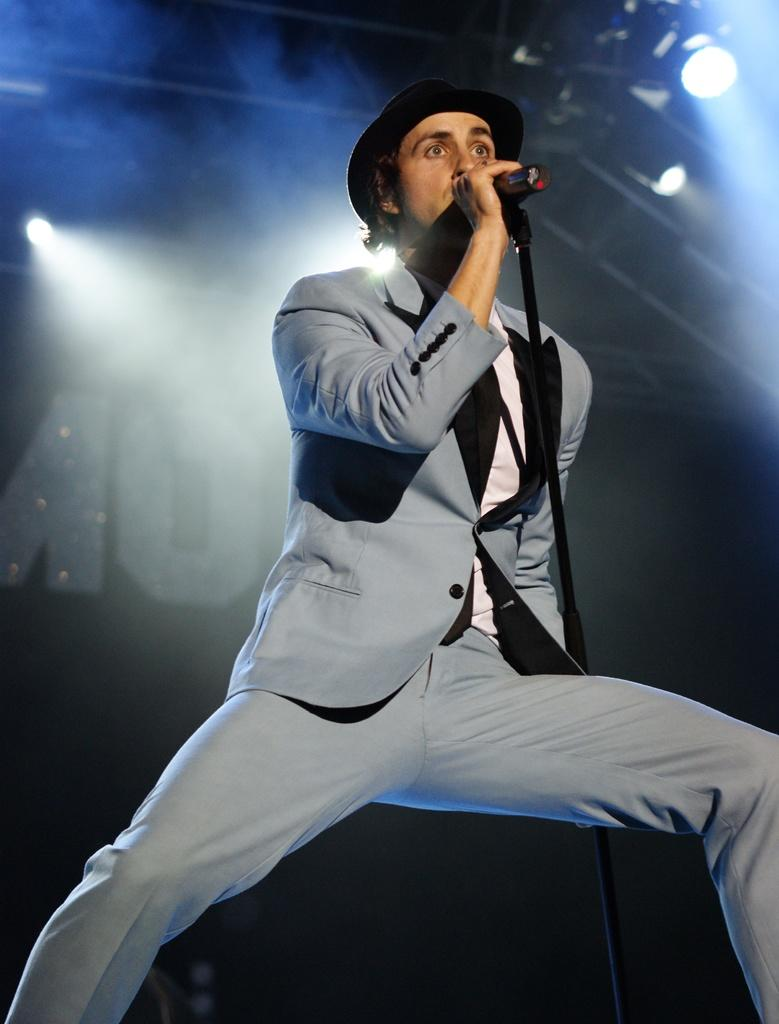What is the person in the image doing? The person is singing on a microphone. What type of clothing is the person wearing? The person is wearing a grey blazer and grey trousers. What accessory is the person wearing on their head? The person is wearing a black hat. What can be seen in the background of the image? There are lights in the background of the image. Can you tell me how many mittens the person is wearing in the image? There are no mittens present in the image. What impulse might have caused the person to start singing on a microphone? The image does not provide information about the person's motivation or impulse for singing on a microphone. 